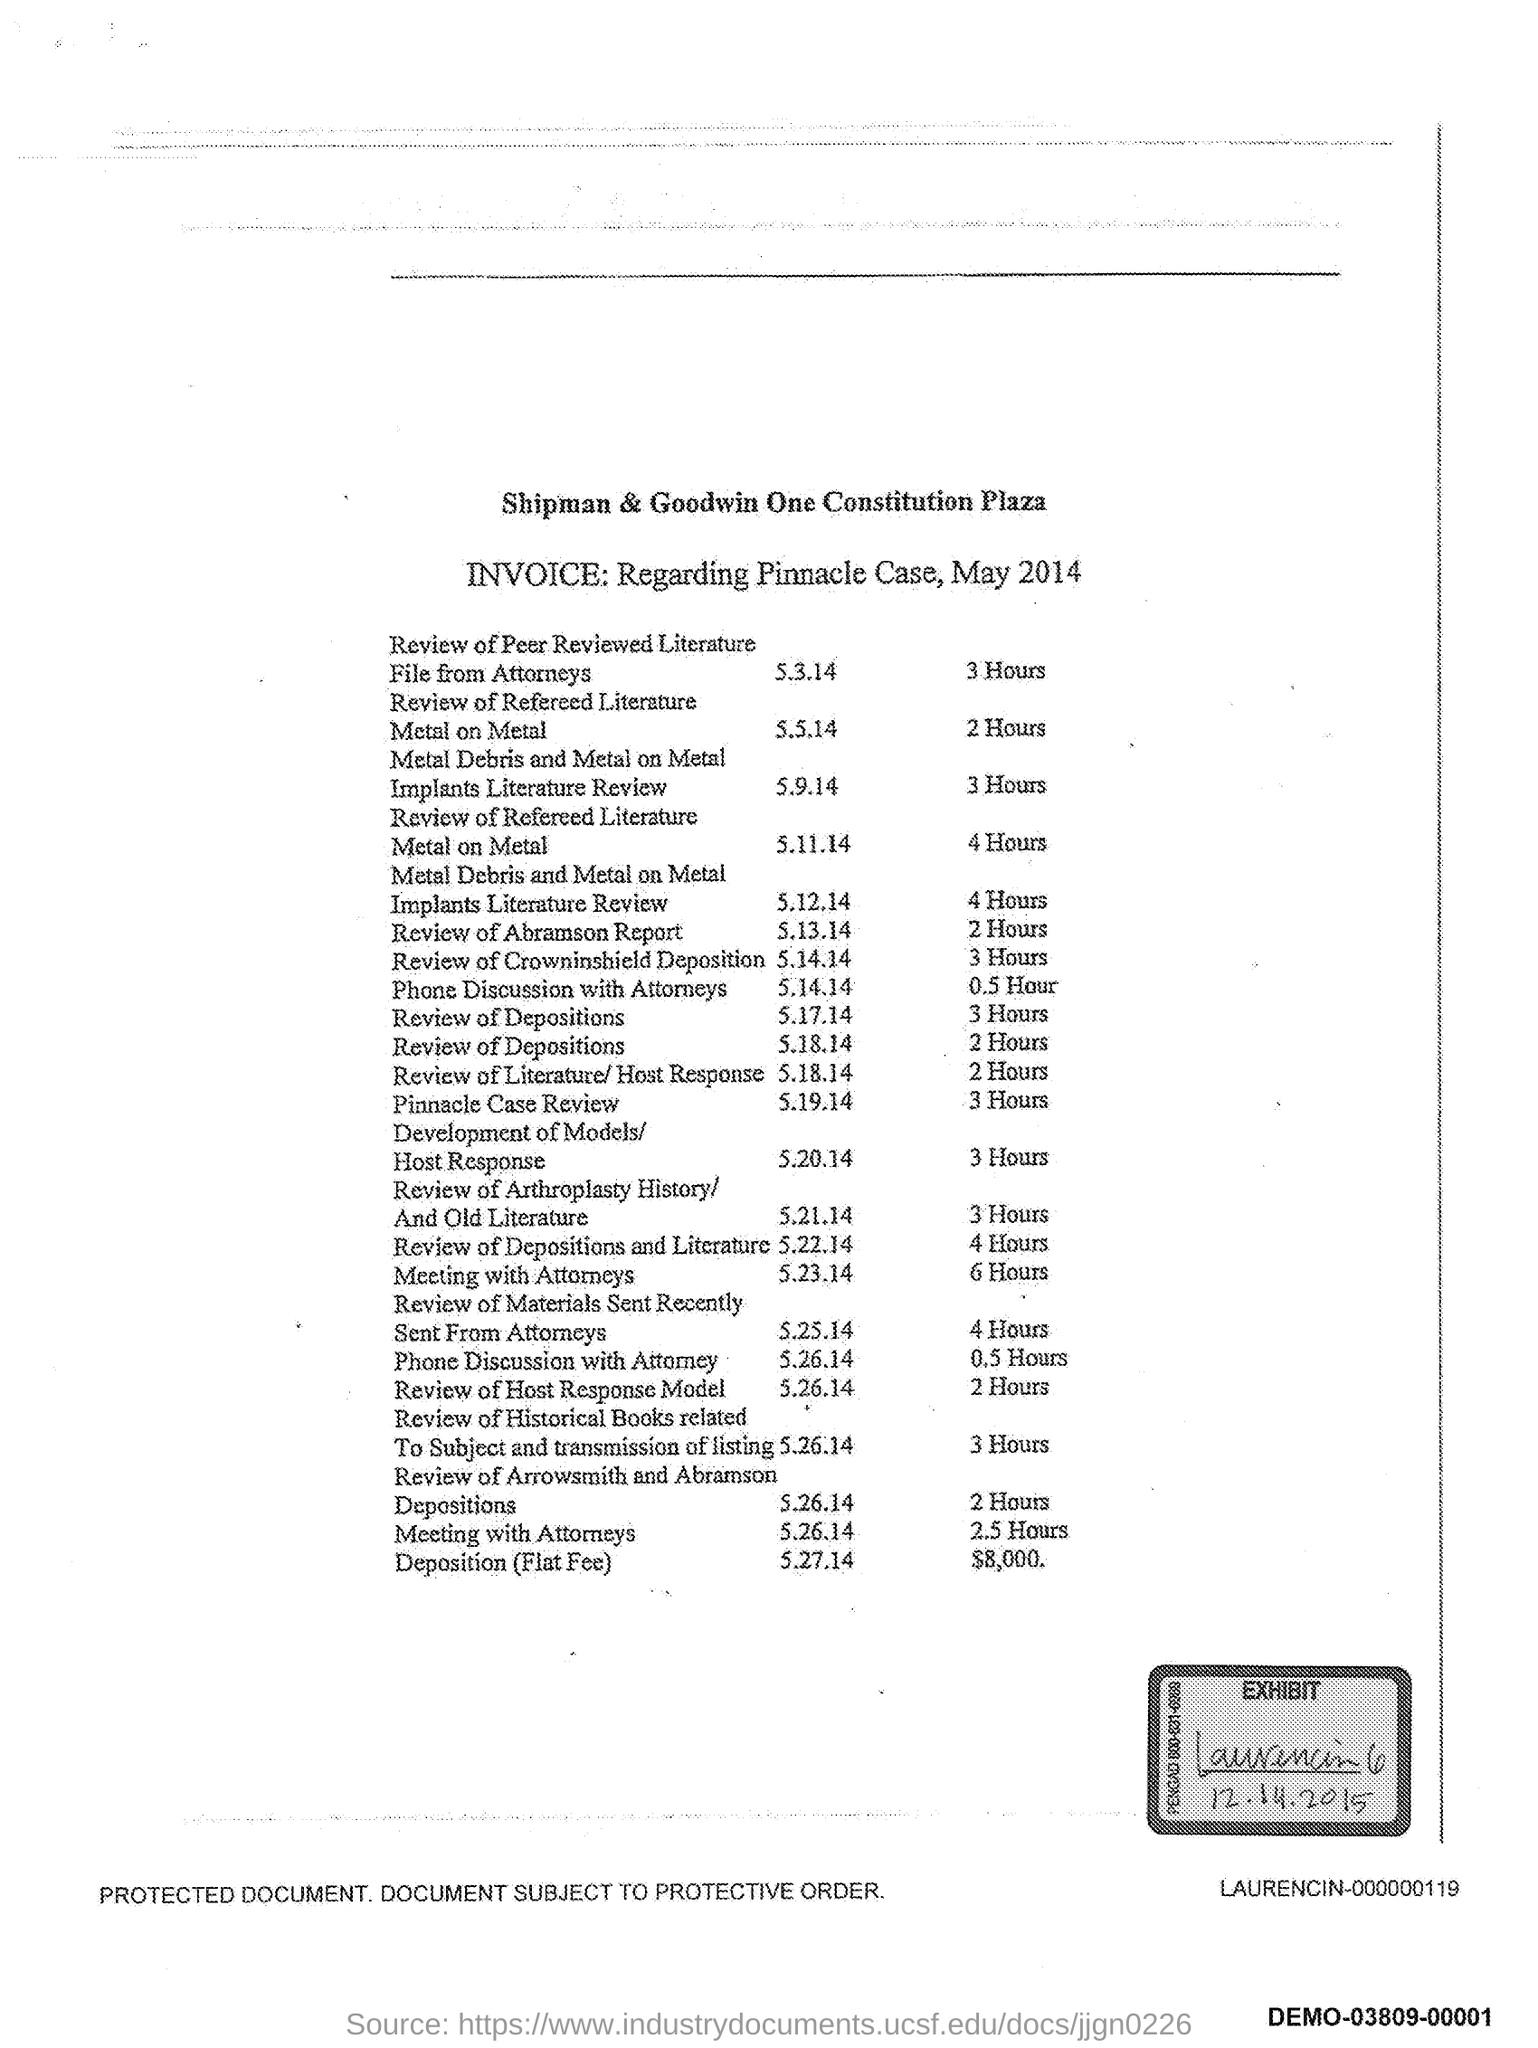What is the invoice in regard to?
Offer a very short reply. Regarding Pinnacle Case, May 2014. What is the exhibit date given in the document?
Offer a terse response. 12.14.2015. What is the time in hours mentioned for meeting with attorneys?
Ensure brevity in your answer.  2.5. What is the time in hours mentioned for review of Abramson report?
Give a very brief answer. 2 Hours. What date is the review of the Crowninshield Deposition held?
Your answer should be very brief. 5.14.14. 